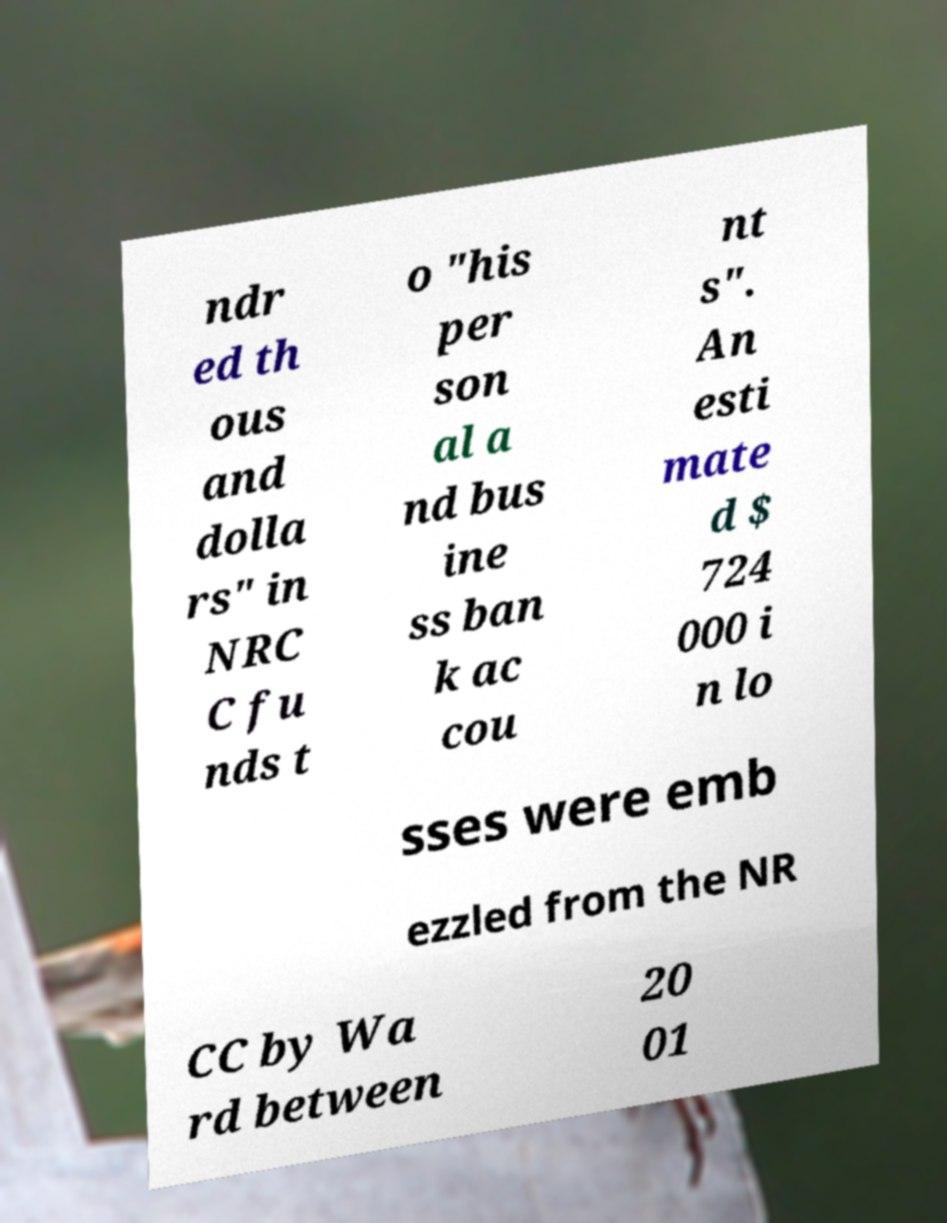Please read and relay the text visible in this image. What does it say? ndr ed th ous and dolla rs" in NRC C fu nds t o "his per son al a nd bus ine ss ban k ac cou nt s". An esti mate d $ 724 000 i n lo sses were emb ezzled from the NR CC by Wa rd between 20 01 